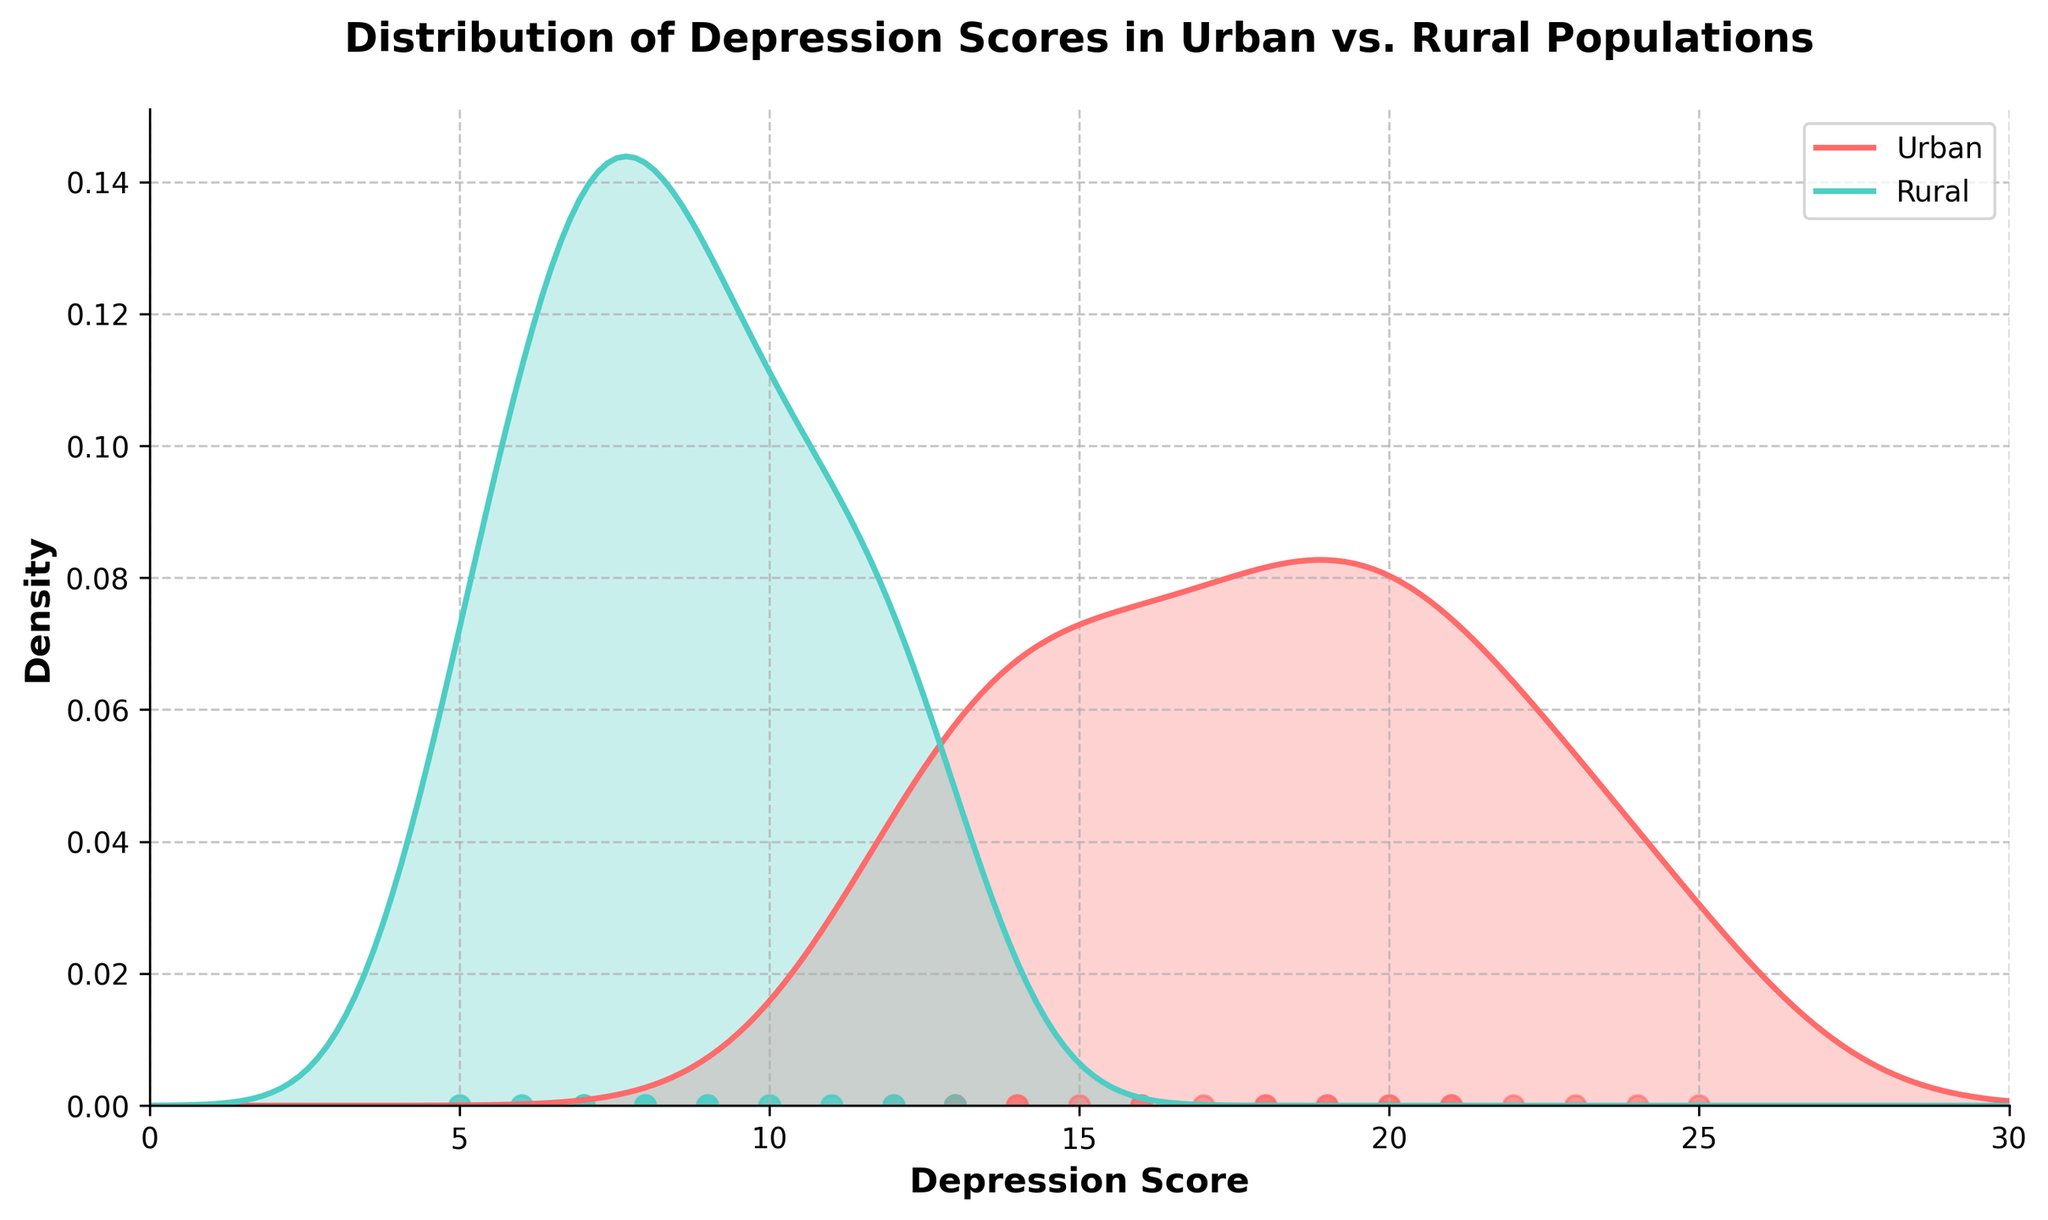What is the title of the figure? The title is likely displayed prominently at the top of the figure. It summarizes the content of the figure, which is about comparing depression scores between urban and rural populations.
Answer: Distribution of Depression Scores in Urban vs. Rural Populations What do the colors red and teal represent in the figure? Different colors are used in the plot to distinguish between the two groups. Typically, a legend is provided to show what each color represents. The red color represents urban scores, and the teal color represents rural scores.
Answer: Urban (red) and Rural (teal) Whose depression score distribution appears to have a higher peak density? The peak density can be observed by looking at the highest points of the KDE curves. From the figure, one can compare the maximum density values of both the urban and rural distributions to determine which is higher.
Answer: Rural Between what two values does the highest density of urban depression scores lie? To determine where the highest density lies, look for the range of x-values under the peak of the red curve. The highest density area for urban depression scores is around its peak.
Answer: Between 15 and 20 Which group has a wider spread of depression scores? A wider spread would be indicated by a broader curve along the x-axis. This requires comparing the width of both curves.
Answer: Urban What is the approximate value of the highest density in the rural depression score distribution? The value can be determined by finding the peak of the teal KDE curve on the y-axis. The height of the highest point on this curve gives the approximate density value.
Answer: Approximately 0.15 Which group has more clustered depression scores around 18-19? Comparing the heights of the KDE curves around the scores of 18-19 will indicate which group has a higher density of scores in that range.
Answer: Urban Are there any depression scores below 5 in either group? One can check the scatter plots at the bottom of the figure to see if there are any points representing depression scores below 5 for either group.
Answer: No What range of depression scores is unique to the rural population? By comparing the x-axis ranges for each KDE plot and looking at the scatter points, one can determine which depression scores are unique to rural populations.
Answer: Above 22 How does the overall shape of the depression score distribution curves differ between urban and rural populations? The overall shape can be inferred by analyzing the KDE curves. Urban scores might show a more uniform or varied spread, while rural scores might appear more concentrated or peaked.
Answer: Urban is more spread, Rural is more peaked 